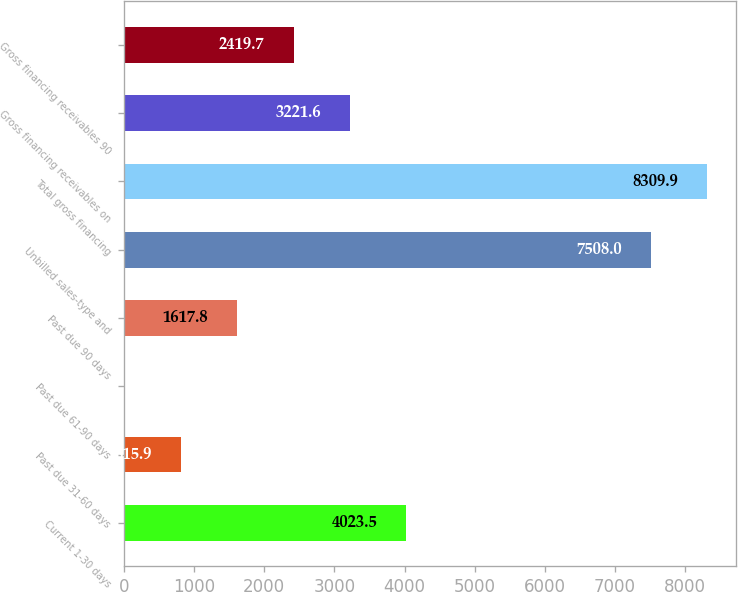Convert chart to OTSL. <chart><loc_0><loc_0><loc_500><loc_500><bar_chart><fcel>Current 1-30 days<fcel>Past due 31-60 days<fcel>Past due 61-90 days<fcel>Past due 90 days<fcel>Unbilled sales-type and<fcel>Total gross financing<fcel>Gross financing receivables on<fcel>Gross financing receivables 90<nl><fcel>4023.5<fcel>815.9<fcel>14<fcel>1617.8<fcel>7508<fcel>8309.9<fcel>3221.6<fcel>2419.7<nl></chart> 